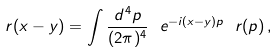<formula> <loc_0><loc_0><loc_500><loc_500>r ( x - y ) = \int \frac { d ^ { 4 } p } { ( 2 \pi ) ^ { 4 } } \ e ^ { - i ( x - y ) p } \ r ( p ) \, ,</formula> 